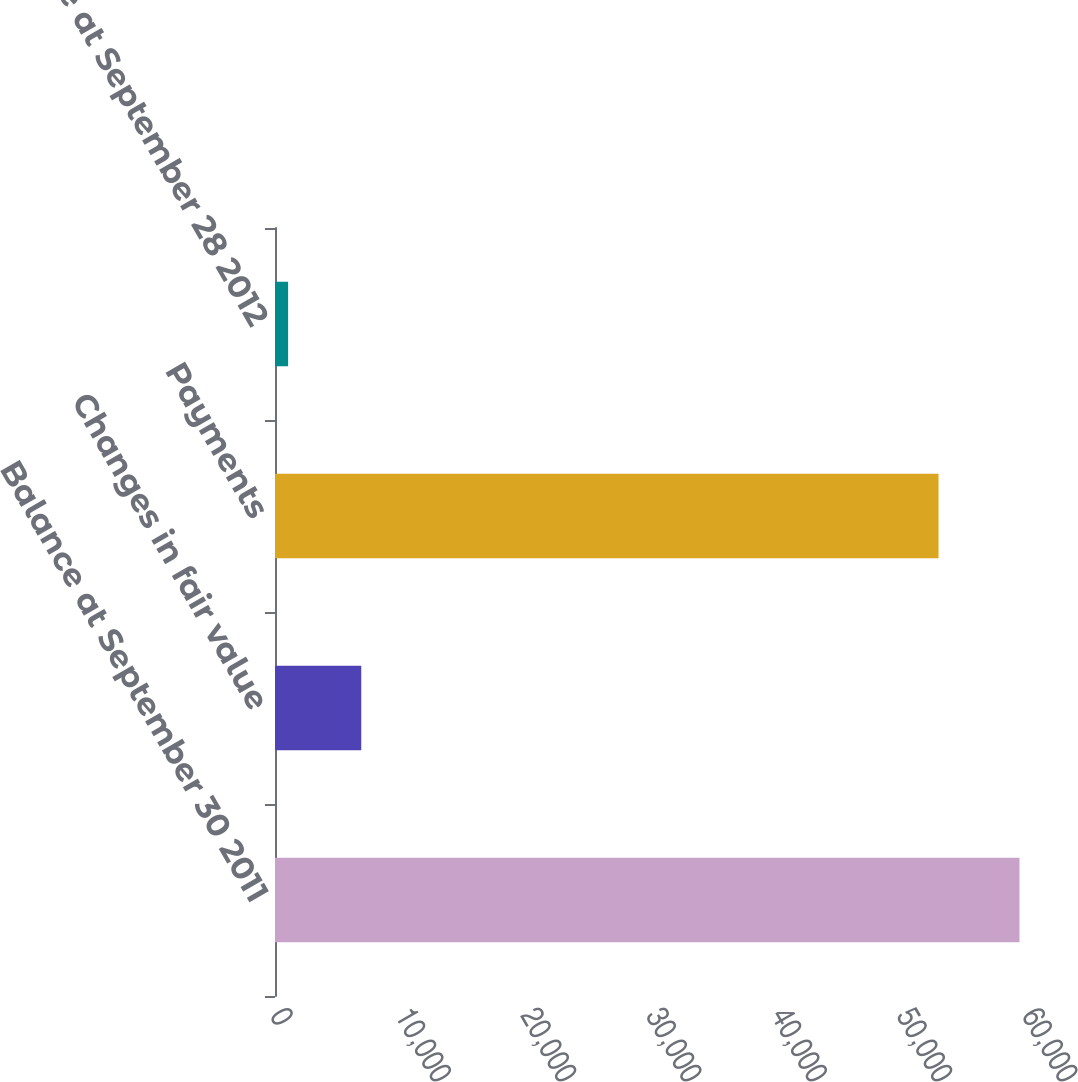Convert chart. <chart><loc_0><loc_0><loc_500><loc_500><bar_chart><fcel>Balance at September 30 2011<fcel>Changes in fair value<fcel>Payments<fcel>Balance at September 28 2012<nl><fcel>59400<fcel>6881.4<fcel>52940<fcel>1046<nl></chart> 